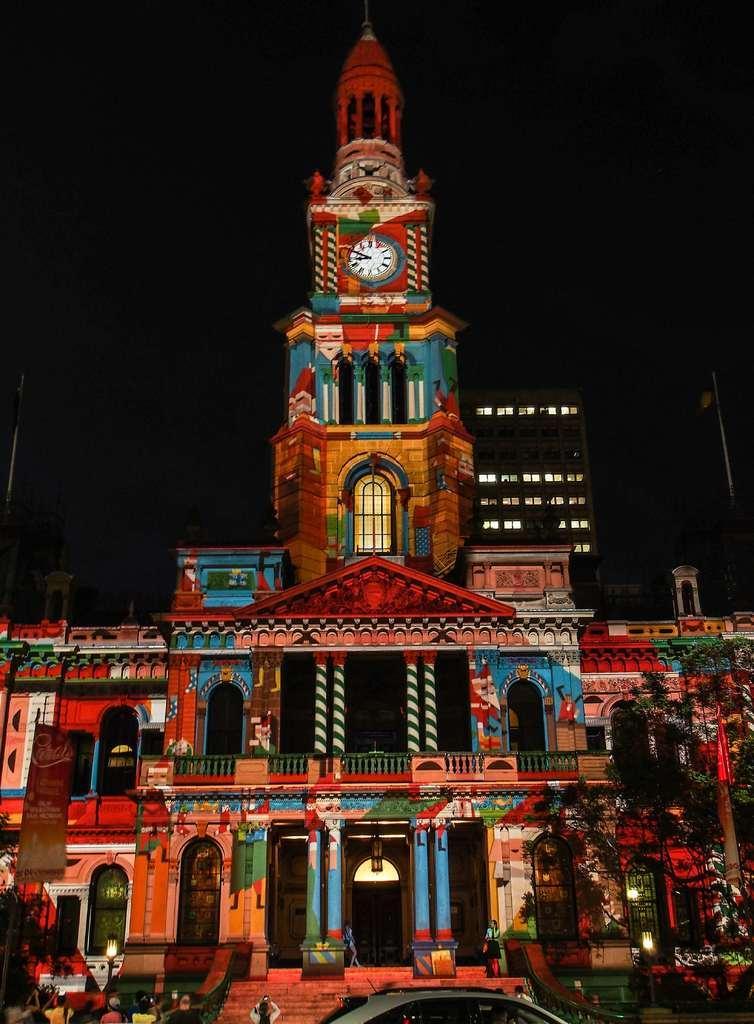In one or two sentences, can you explain what this image depicts? In this image I can see there is a building and it has a tower with a clock, the sky is dark and clear. 